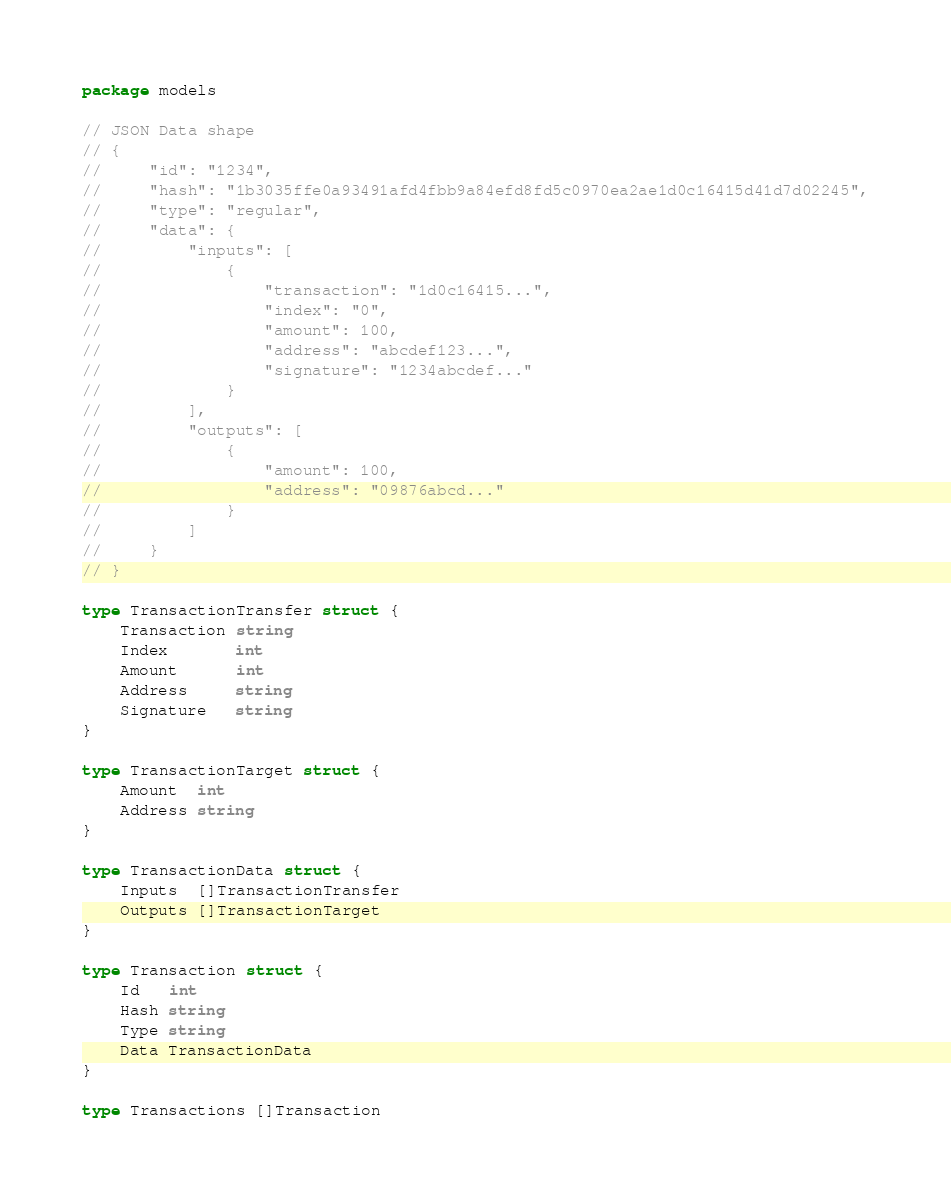Convert code to text. <code><loc_0><loc_0><loc_500><loc_500><_Go_>package models

// JSON Data shape
// {
//     "id": "1234",
//     "hash": "1b3035ffe0a93491afd4fbb9a84efd8fd5c0970ea2ae1d0c16415d41d7d02245",
//     "type": "regular",
//     "data": {
//         "inputs": [
//             {
//                 "transaction": "1d0c16415...",
//                 "index": "0",
//                 "amount": 100,
//                 "address": "abcdef123...",
//                 "signature": "1234abcdef..."
//             }
//         ],
//         "outputs": [
//             {
//                 "amount": 100,
//                 "address": "09876abcd..."
//             }
//         ]
//     }
// }

type TransactionTransfer struct {
	Transaction string
	Index       int
	Amount      int
	Address     string
	Signature   string
}

type TransactionTarget struct {
	Amount  int
	Address string
}

type TransactionData struct {
	Inputs  []TransactionTransfer
	Outputs []TransactionTarget
}

type Transaction struct {
	Id   int
	Hash string
	Type string
	Data TransactionData
}

type Transactions []Transaction
</code> 